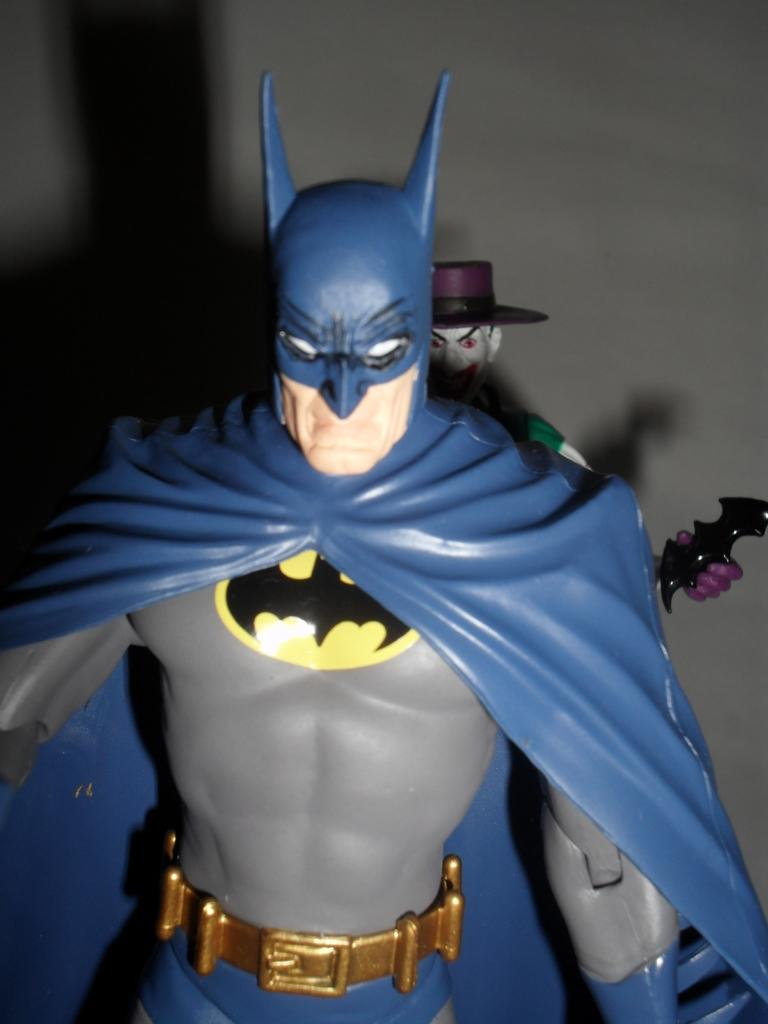What object can be seen in the image? There is a toy in the image. Can you describe any additional features related to the toy? There is a shadow of the toy on the left side of the image. What type of animal can be seen in the image? There is no animal present in the image; it features a toy and its shadow. What property is associated with the toy in the image? The toy's shadow is visible on the left side of the image, but there is no mention of any specific property related to the toy itself. 